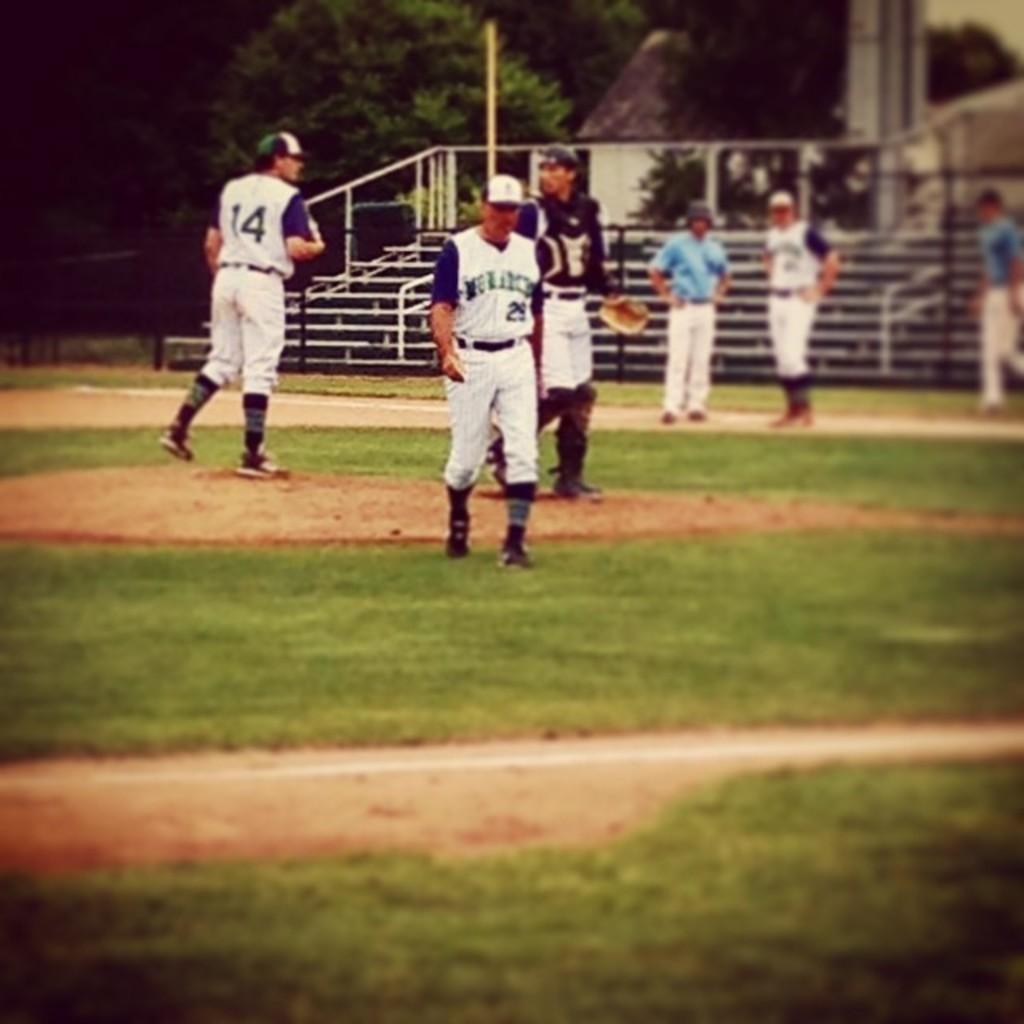What is happening on the ground in the image? There are players on the ground in the image. What can be seen in the background of the image? There are stairs and trees visible in the background of the image. What type of stem can be seen growing from the mouth of one of the players in the image? There is no stem or mouth visible on any of the players in the image. Is there a bridge connecting the stairs and trees in the background of the image? There is no bridge present in the image; only stairs and trees are visible in the background. 